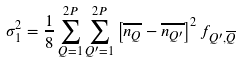<formula> <loc_0><loc_0><loc_500><loc_500>\sigma _ { 1 } ^ { 2 } = \frac { 1 } { 8 } \sum _ { Q = 1 } ^ { 2 P } \sum _ { Q ^ { \prime } = 1 } ^ { 2 P } \left [ \overline { n _ { Q } } - \overline { n _ { Q ^ { \prime } } } \right ] ^ { 2 } f _ { Q ^ { \prime } , \overline { Q } }</formula> 